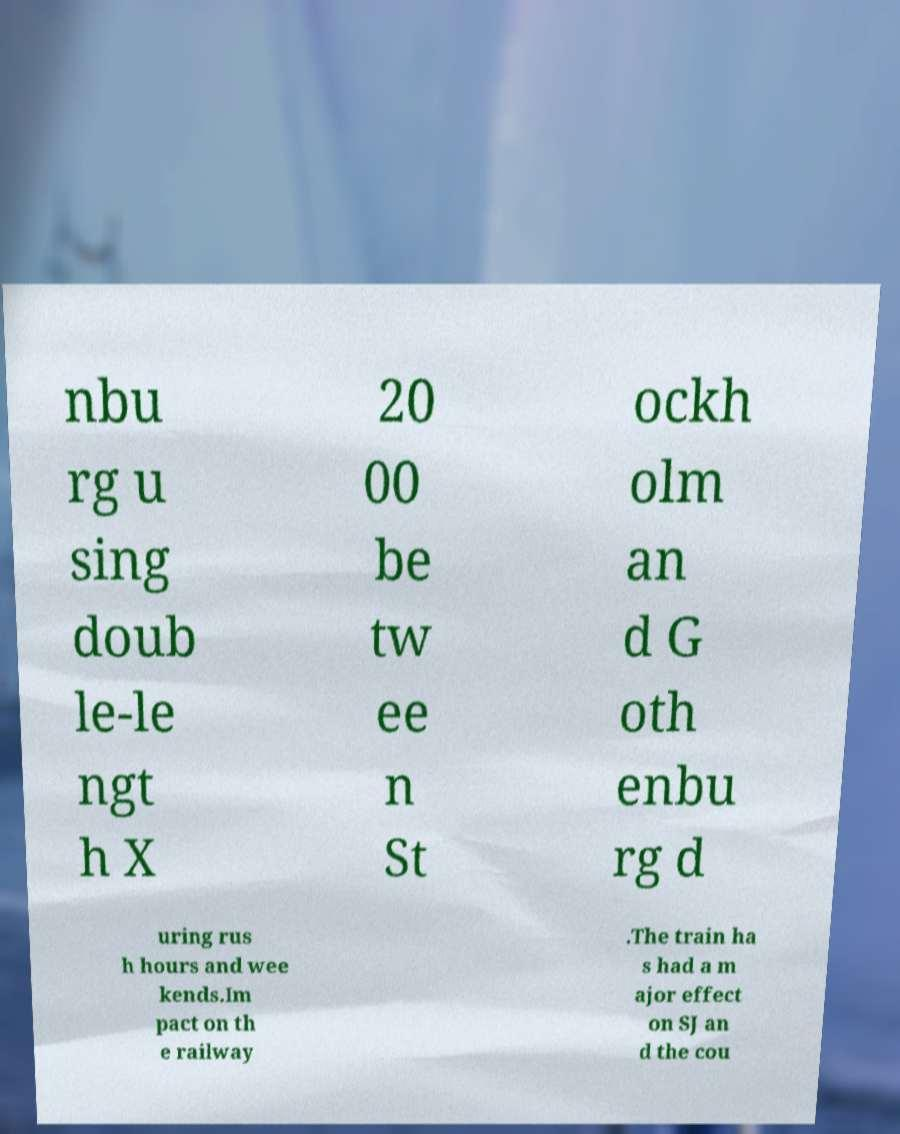Could you assist in decoding the text presented in this image and type it out clearly? nbu rg u sing doub le-le ngt h X 20 00 be tw ee n St ockh olm an d G oth enbu rg d uring rus h hours and wee kends.Im pact on th e railway .The train ha s had a m ajor effect on SJ an d the cou 